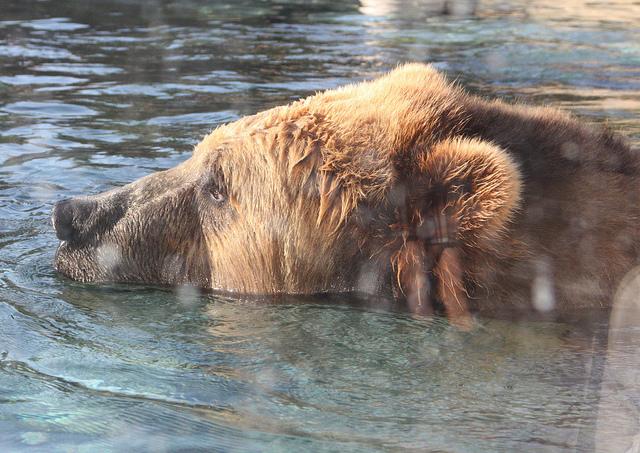What kind of bear is this?
Keep it brief. Grizzly. What animal is this?
Give a very brief answer. Bear. Where is the animal?
Keep it brief. In water. 